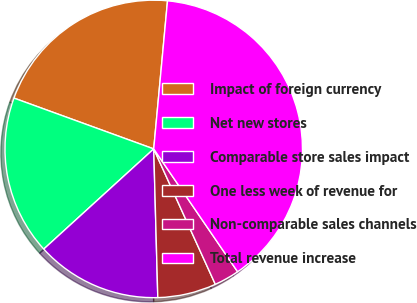<chart> <loc_0><loc_0><loc_500><loc_500><pie_chart><fcel>Impact of foreign currency<fcel>Net new stores<fcel>Comparable store sales impact<fcel>One less week of revenue for<fcel>Non-comparable sales channels<fcel>Total revenue increase<nl><fcel>20.93%<fcel>17.31%<fcel>13.68%<fcel>6.36%<fcel>2.74%<fcel>38.99%<nl></chart> 